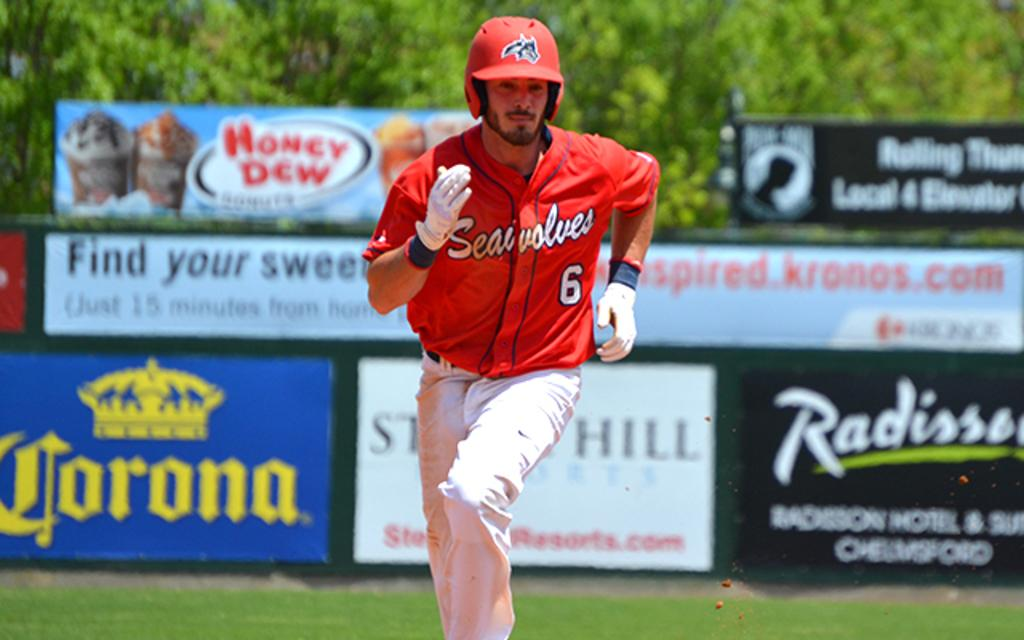<image>
Write a terse but informative summary of the picture. A baseball player in a Seawolves uniform runs to the next base. 